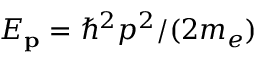<formula> <loc_0><loc_0><loc_500><loc_500>E _ { p } = \hbar { ^ } { 2 } p ^ { 2 } / ( 2 m _ { e } )</formula> 